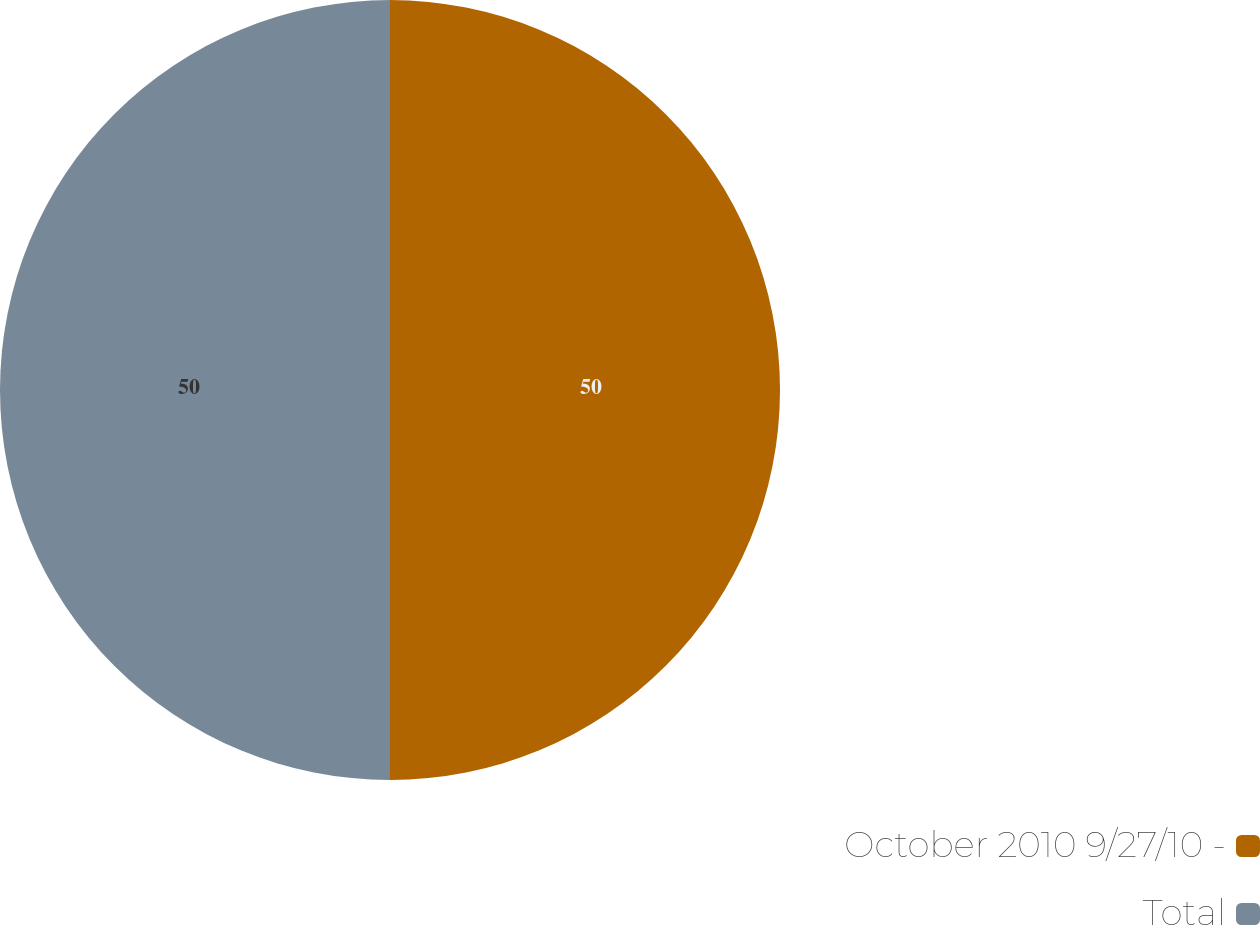<chart> <loc_0><loc_0><loc_500><loc_500><pie_chart><fcel>October 2010 9/27/10 -<fcel>Total<nl><fcel>50.0%<fcel>50.0%<nl></chart> 